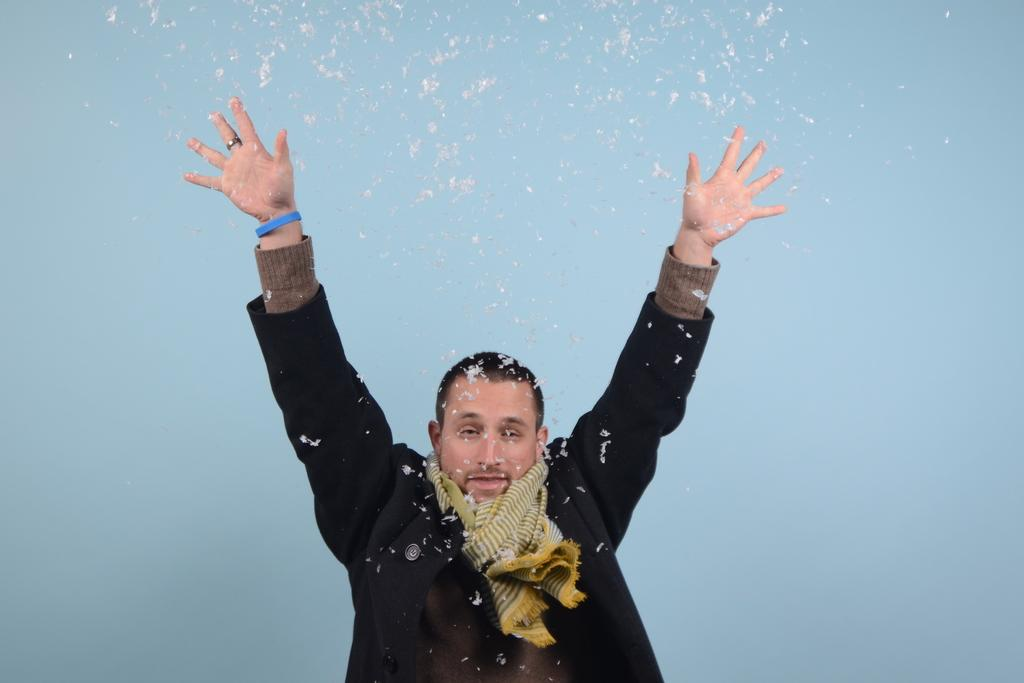Who is the main subject in the image? There is a man in the image. Where is the man located in the image? The man is in the middle of the image. What is the man doing in the image? The man is raising his hand. What is the man wearing in the image? The man is wearing a black coat and a scarf. What is unusual about the man's appearance in the image? There are feathers at the top of the man. What type of structure can be seen on the roof of the man in the image? There is no roof present in the image, as the man is not depicted as being part of a building or structure. 